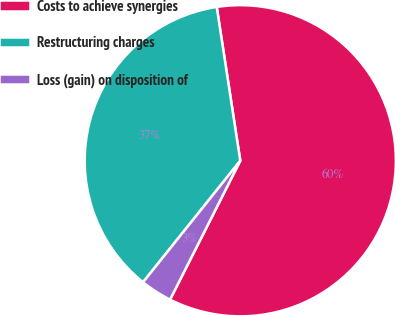Convert chart. <chart><loc_0><loc_0><loc_500><loc_500><pie_chart><fcel>Costs to achieve synergies<fcel>Restructuring charges<fcel>Loss (gain) on disposition of<nl><fcel>59.87%<fcel>36.84%<fcel>3.29%<nl></chart> 